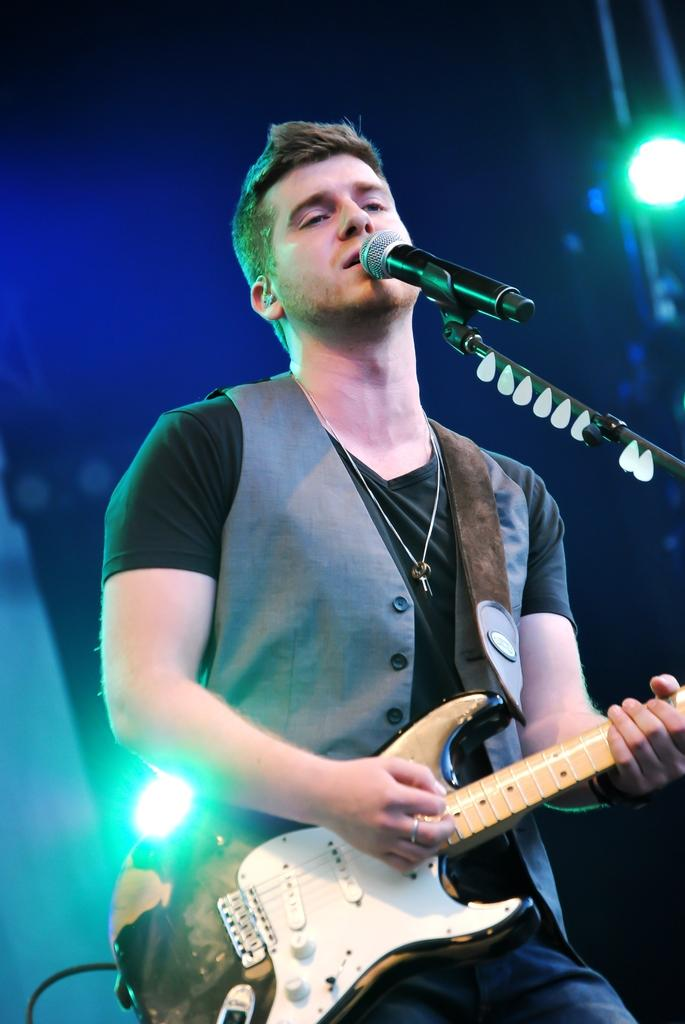What is the main subject of the image? There is a man in the image. What is the man doing in the image? The man is standing and holding a guitar. What object is in front of the man? There is a microphone in front of the man. What can be seen in the background of the image? There are lights visible in the background. What type of magic is the man performing with the glass in the image? There is no glass present in the image, and the man is not performing any magic. 